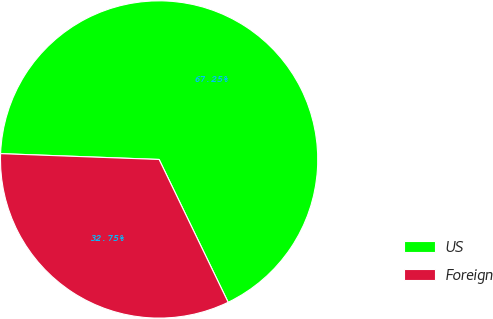<chart> <loc_0><loc_0><loc_500><loc_500><pie_chart><fcel>US<fcel>Foreign<nl><fcel>67.25%<fcel>32.75%<nl></chart> 